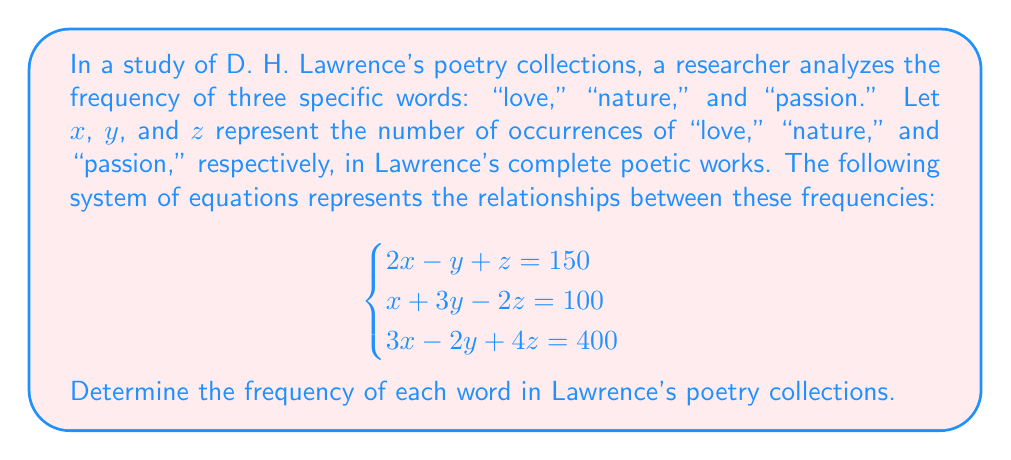Could you help me with this problem? To solve this system of equations, we'll use the elimination method:

1) Multiply the first equation by 3 and the second equation by -2:
   $$\begin{cases}
   6x - 3y + 3z = 450 \\
   -2x - 6y + 4z = -200
   \end{cases}$$

2) Add these equations to eliminate x:
   $$4x - 9y + 7z = 250$$ (Equation A)

3) Now, multiply the original first equation by -1 and add it to the third equation:
   $$\begin{cases}
   -2x + y - z = -150 \\
   3x - 2y + 4z = 400
   \end{cases}$$
   
   Adding these:
   $$x - y + 3z = 250$$ (Equation B)

4) Multiply Equation B by 9 and Equation A by -1:
   $$\begin{cases}
   9x - 9y + 27z = 2250 \\
   -4x + 9y - 7z = -250
   \end{cases}$$

5) Add these equations to eliminate y:
   $$5x + 20z = 2000$$

6) Divide by 5:
   $$x + 4z = 400$$ (Equation C)

7) Substitute this expression for x into Equation B:
   $$(400 - 4z) - y + 3z = 250$$
   $$400 - 4z - y + 3z = 250$$
   $$400 - z - y = 250$$
   $$-z - y = -150$$
   $$y + z = 150$$ (Equation D)

8) Now we have two equations with two unknowns (C and D). Solve for z:
   $$\begin{cases}
   x + 4z = 400 \\
   y + z = 150
   \end{cases}$$
   
   Substitute $y = 150 - z$ into the first equation of the original system:
   $$2x - (150 - z) + z = 150$$
   $$2x - 150 + 2z = 150$$
   $$2x + 2z = 300$$
   $$x + z = 150$$ (Equation E)

9) Compare Equations C and E:
   $$\begin{cases}
   x + 4z = 400 \\
   x + z = 150
   \end{cases}$$
   
   Subtracting the second from the first:
   $$3z = 250$$
   $$z = \frac{250}{3} \approx 83.33$$

10) Substitute this value back into Equation E to find x:
    $$x + 83.33 = 150$$
    $$x = 66.67$$

11) Finally, use Equation D to find y:
    $$y + 83.33 = 150$$
    $$y = 66.67$$
Answer: The frequencies of the words in D. H. Lawrence's poetry collections are:
"love" (x): 67 occurrences
"nature" (y): 67 occurrences
"passion" (z): 83 occurrences
(rounded to the nearest whole number) 